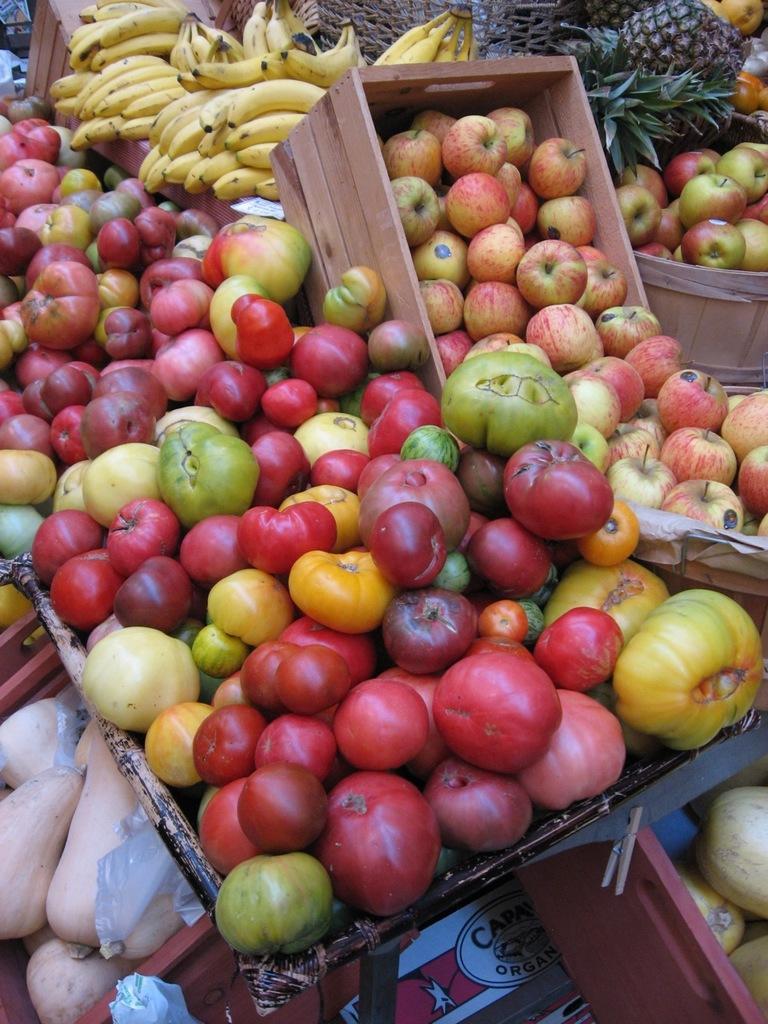In one or two sentences, can you explain what this image depicts? In this picture there are different types of fruits like apples, bananas, pineapples and some other fruits in the basket. 